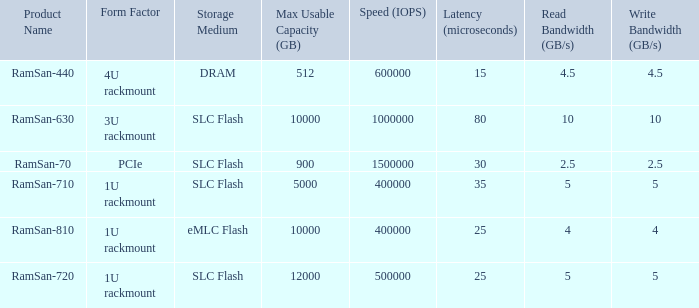What is the Input/output operations per second for the emlc flash? 400000.0. 